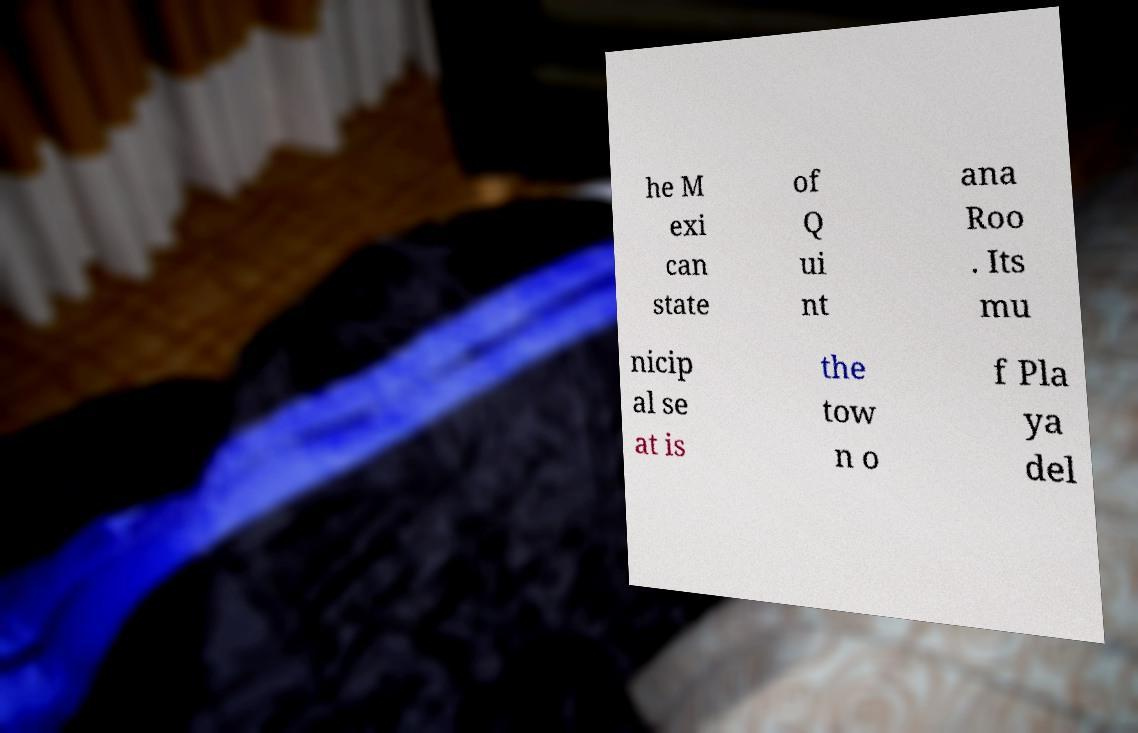Can you accurately transcribe the text from the provided image for me? he M exi can state of Q ui nt ana Roo . Its mu nicip al se at is the tow n o f Pla ya del 